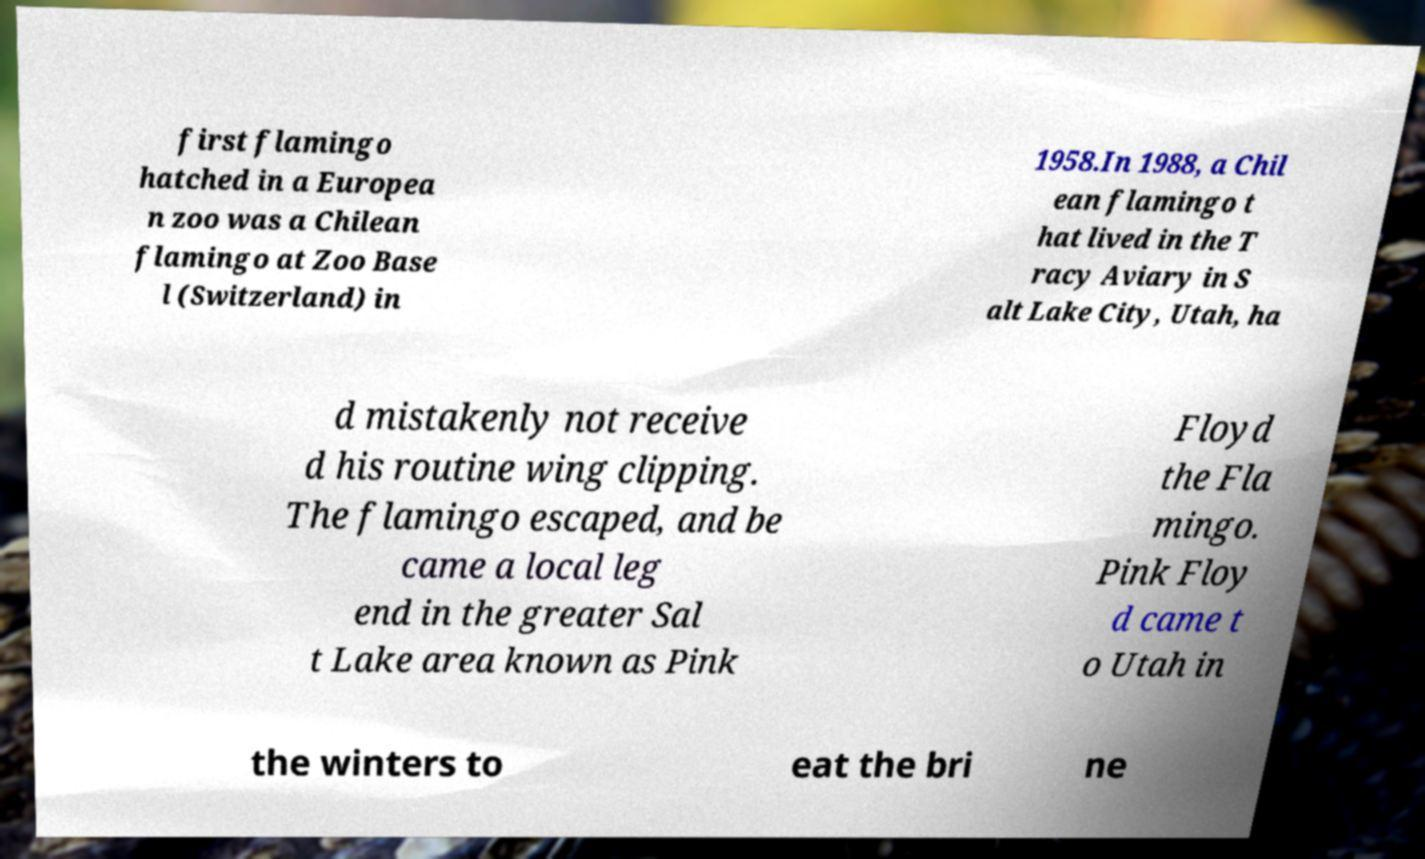For documentation purposes, I need the text within this image transcribed. Could you provide that? first flamingo hatched in a Europea n zoo was a Chilean flamingo at Zoo Base l (Switzerland) in 1958.In 1988, a Chil ean flamingo t hat lived in the T racy Aviary in S alt Lake City, Utah, ha d mistakenly not receive d his routine wing clipping. The flamingo escaped, and be came a local leg end in the greater Sal t Lake area known as Pink Floyd the Fla mingo. Pink Floy d came t o Utah in the winters to eat the bri ne 